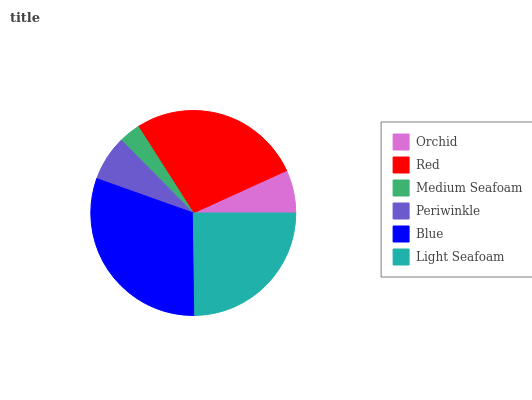Is Medium Seafoam the minimum?
Answer yes or no. Yes. Is Blue the maximum?
Answer yes or no. Yes. Is Red the minimum?
Answer yes or no. No. Is Red the maximum?
Answer yes or no. No. Is Red greater than Orchid?
Answer yes or no. Yes. Is Orchid less than Red?
Answer yes or no. Yes. Is Orchid greater than Red?
Answer yes or no. No. Is Red less than Orchid?
Answer yes or no. No. Is Light Seafoam the high median?
Answer yes or no. Yes. Is Periwinkle the low median?
Answer yes or no. Yes. Is Blue the high median?
Answer yes or no. No. Is Light Seafoam the low median?
Answer yes or no. No. 